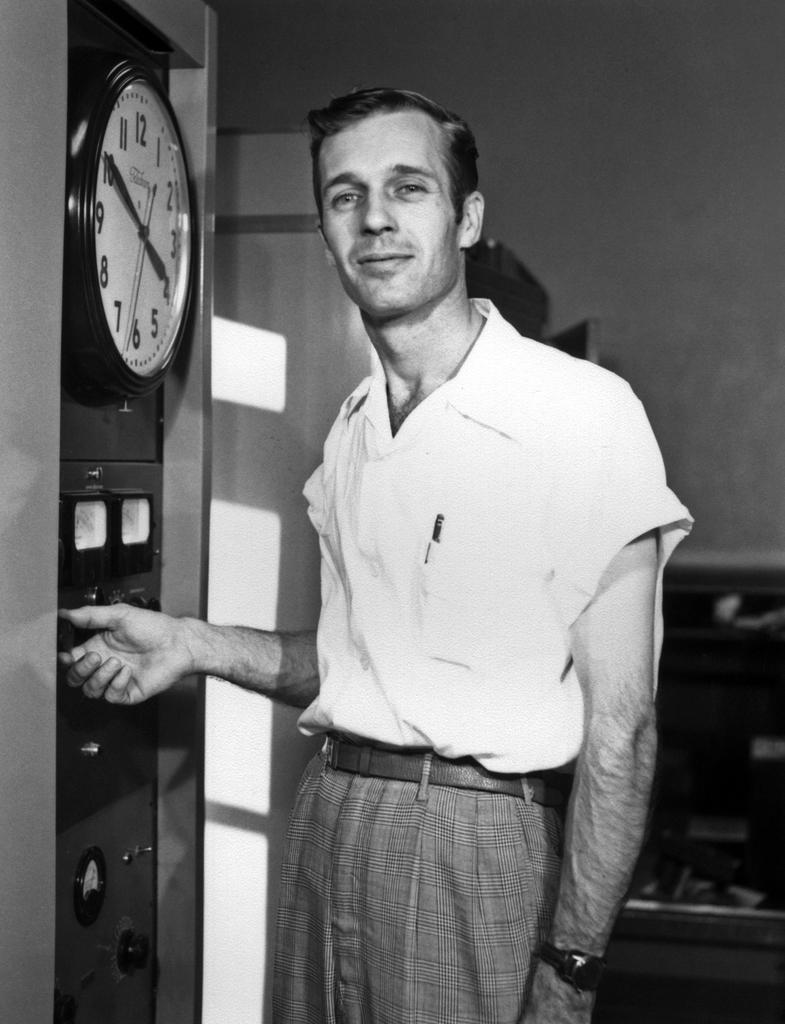<image>
Render a clear and concise summary of the photo. A man is touching a dial on a machine with a clock built into it. 